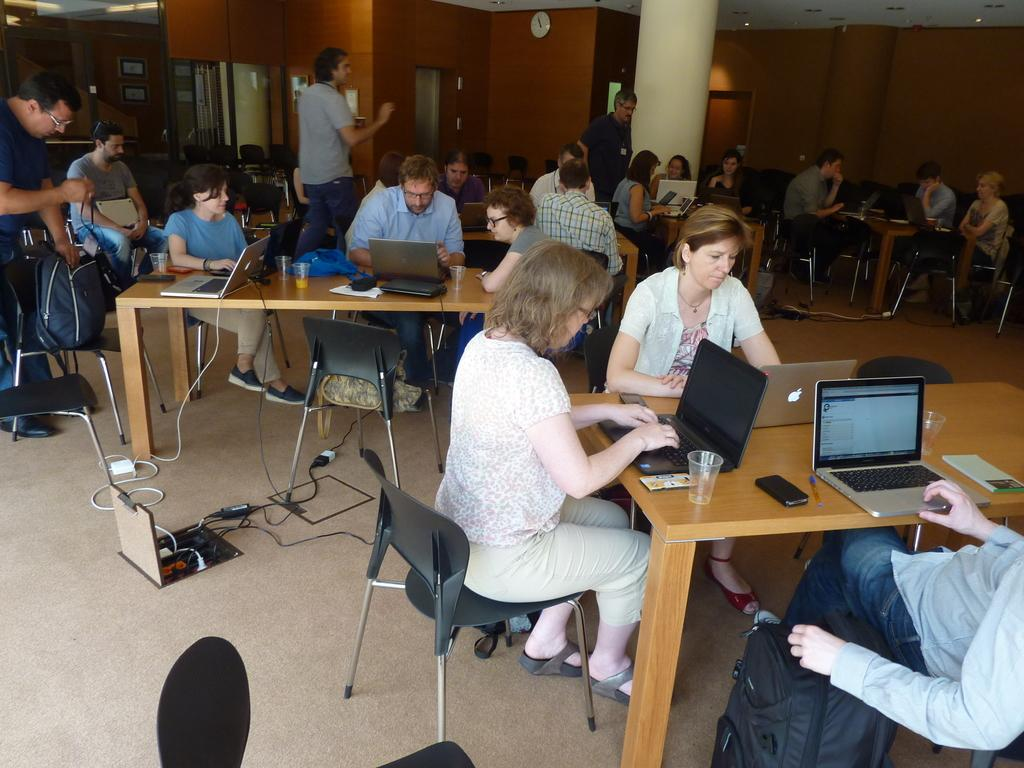What are the people in the image doing? The people in the image are sitting on chairs. What objects can be seen on the table in the image? There are laptops and a mobile phone on the table in the image. What type of clover is being used as a bookmark in the image? There is no clover present in the image, nor is there any indication of a bookmark. 